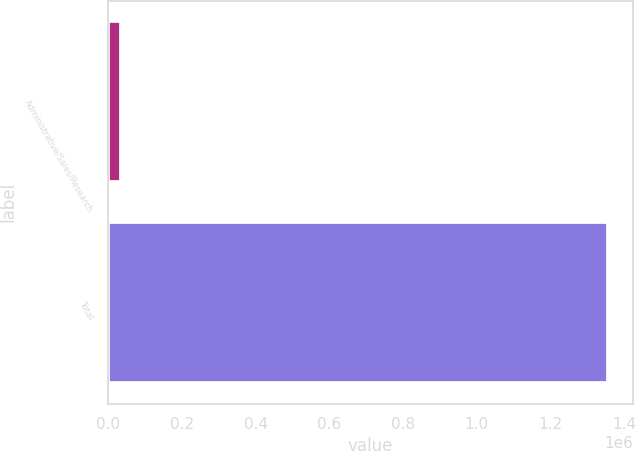<chart> <loc_0><loc_0><loc_500><loc_500><bar_chart><fcel>Administrative/Sales/Research<fcel>Total<nl><fcel>34000<fcel>1.356e+06<nl></chart> 